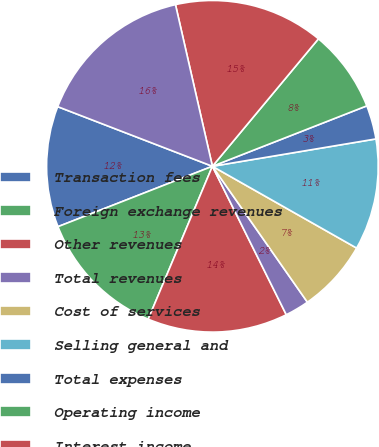<chart> <loc_0><loc_0><loc_500><loc_500><pie_chart><fcel>Transaction fees<fcel>Foreign exchange revenues<fcel>Other revenues<fcel>Total revenues<fcel>Cost of services<fcel>Selling general and<fcel>Total expenses<fcel>Operating income<fcel>Interest income<fcel>Interest expense<nl><fcel>11.79%<fcel>12.74%<fcel>13.68%<fcel>2.36%<fcel>7.08%<fcel>10.85%<fcel>3.3%<fcel>8.02%<fcel>14.62%<fcel>15.57%<nl></chart> 